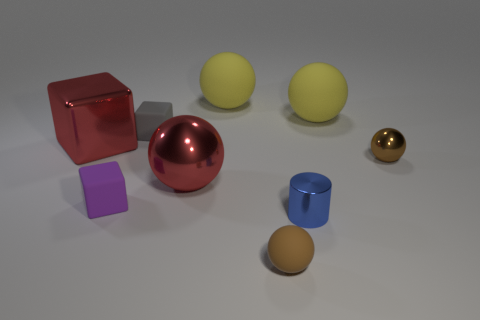Subtract all large shiny blocks. How many blocks are left? 2 Add 1 tiny blocks. How many objects exist? 10 Subtract all cylinders. How many objects are left? 8 Subtract 0 yellow blocks. How many objects are left? 9 Subtract 3 balls. How many balls are left? 2 Subtract all red cubes. Subtract all cyan spheres. How many cubes are left? 2 Subtract all gray cylinders. How many brown spheres are left? 2 Subtract all cubes. Subtract all metallic things. How many objects are left? 2 Add 2 tiny brown spheres. How many tiny brown spheres are left? 4 Add 7 tiny blue balls. How many tiny blue balls exist? 7 